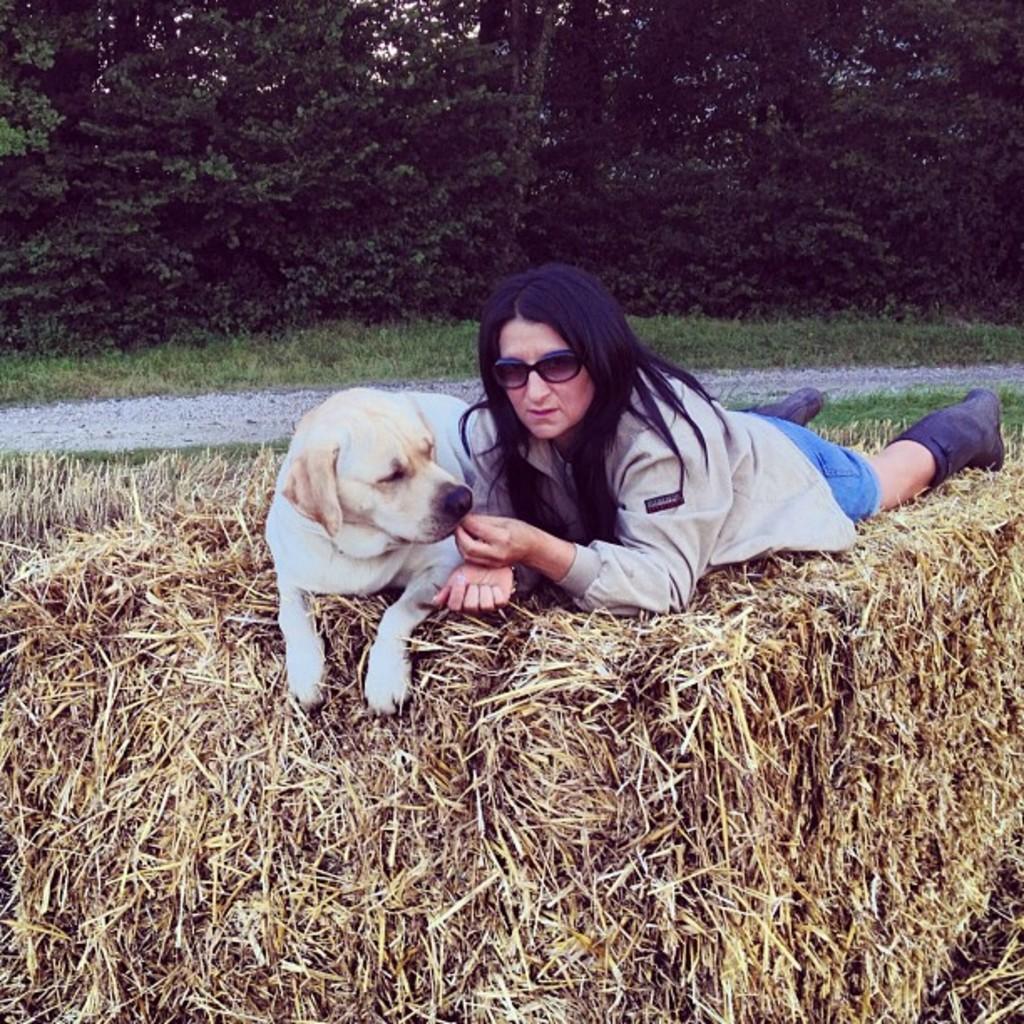Describe this image in one or two sentences. In this picture we can see a woman lying on the grass. She has spectacles and there is a dog. On the background there are trees and this is road. 